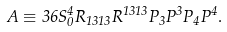Convert formula to latex. <formula><loc_0><loc_0><loc_500><loc_500>A \equiv 3 6 S ^ { 4 } _ { 0 } R _ { 1 3 1 3 } R ^ { 1 3 1 3 } P _ { 3 } P ^ { 3 } P _ { 4 } P ^ { 4 } .</formula> 